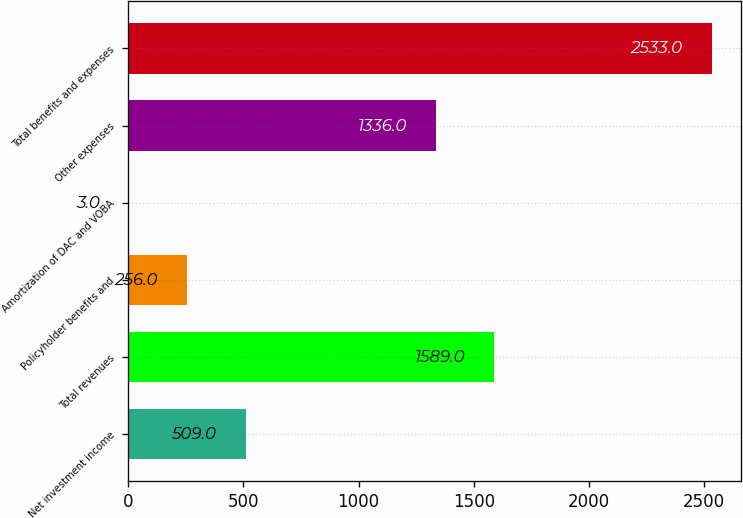Convert chart to OTSL. <chart><loc_0><loc_0><loc_500><loc_500><bar_chart><fcel>Net investment income<fcel>Total revenues<fcel>Policyholder benefits and<fcel>Amortization of DAC and VOBA<fcel>Other expenses<fcel>Total benefits and expenses<nl><fcel>509<fcel>1589<fcel>256<fcel>3<fcel>1336<fcel>2533<nl></chart> 